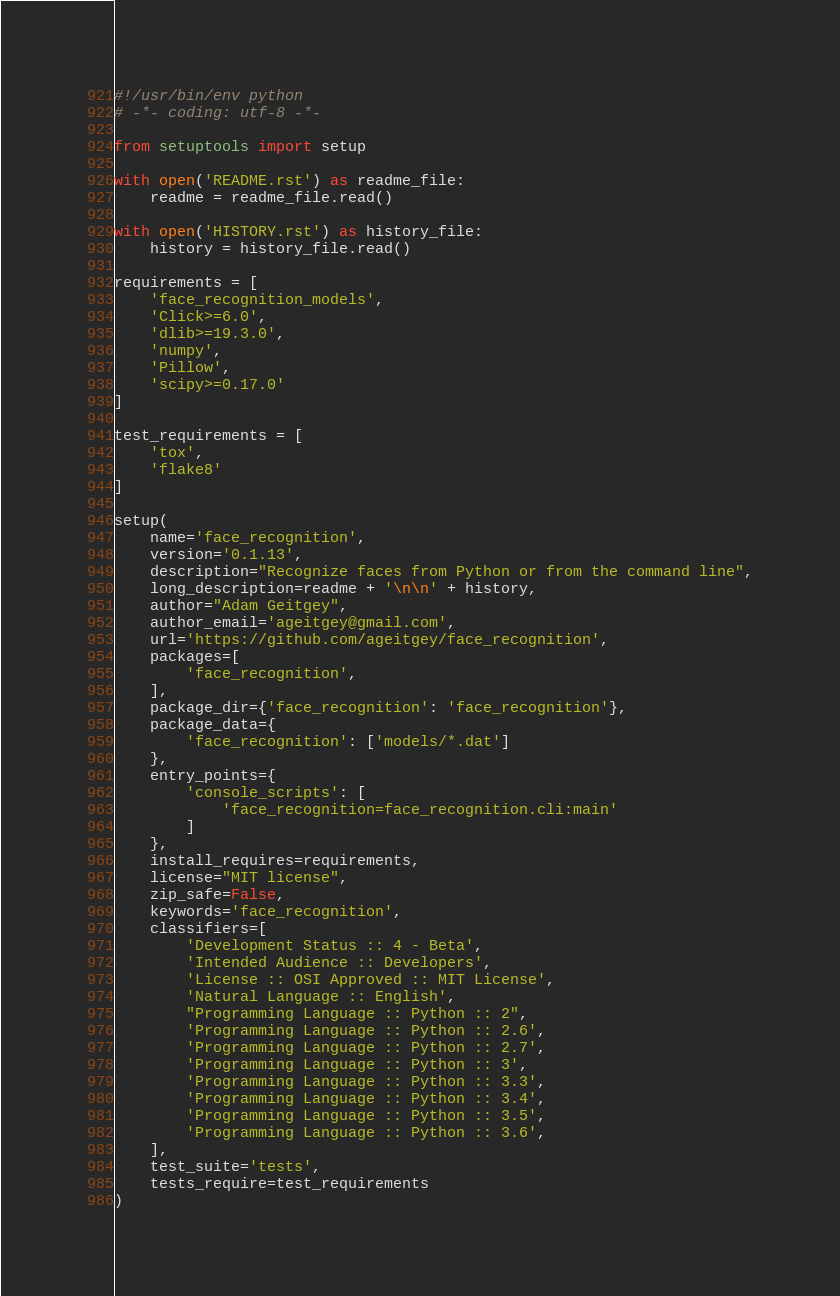<code> <loc_0><loc_0><loc_500><loc_500><_Python_>#!/usr/bin/env python
# -*- coding: utf-8 -*-

from setuptools import setup

with open('README.rst') as readme_file:
    readme = readme_file.read()

with open('HISTORY.rst') as history_file:
    history = history_file.read()

requirements = [
    'face_recognition_models',
    'Click>=6.0',
    'dlib>=19.3.0',
    'numpy',
    'Pillow',
    'scipy>=0.17.0'
]

test_requirements = [
    'tox',
    'flake8'
]

setup(
    name='face_recognition',
    version='0.1.13',
    description="Recognize faces from Python or from the command line",
    long_description=readme + '\n\n' + history,
    author="Adam Geitgey",
    author_email='ageitgey@gmail.com',
    url='https://github.com/ageitgey/face_recognition',
    packages=[
        'face_recognition',
    ],
    package_dir={'face_recognition': 'face_recognition'},
    package_data={
        'face_recognition': ['models/*.dat']
    },
    entry_points={
        'console_scripts': [
            'face_recognition=face_recognition.cli:main'
        ]
    },
    install_requires=requirements,
    license="MIT license",
    zip_safe=False,
    keywords='face_recognition',
    classifiers=[
        'Development Status :: 4 - Beta',
        'Intended Audience :: Developers',
        'License :: OSI Approved :: MIT License',
        'Natural Language :: English',
        "Programming Language :: Python :: 2",
        'Programming Language :: Python :: 2.6',
        'Programming Language :: Python :: 2.7',
        'Programming Language :: Python :: 3',
        'Programming Language :: Python :: 3.3',
        'Programming Language :: Python :: 3.4',
        'Programming Language :: Python :: 3.5',
        'Programming Language :: Python :: 3.6',
    ],
    test_suite='tests',
    tests_require=test_requirements
)
</code> 